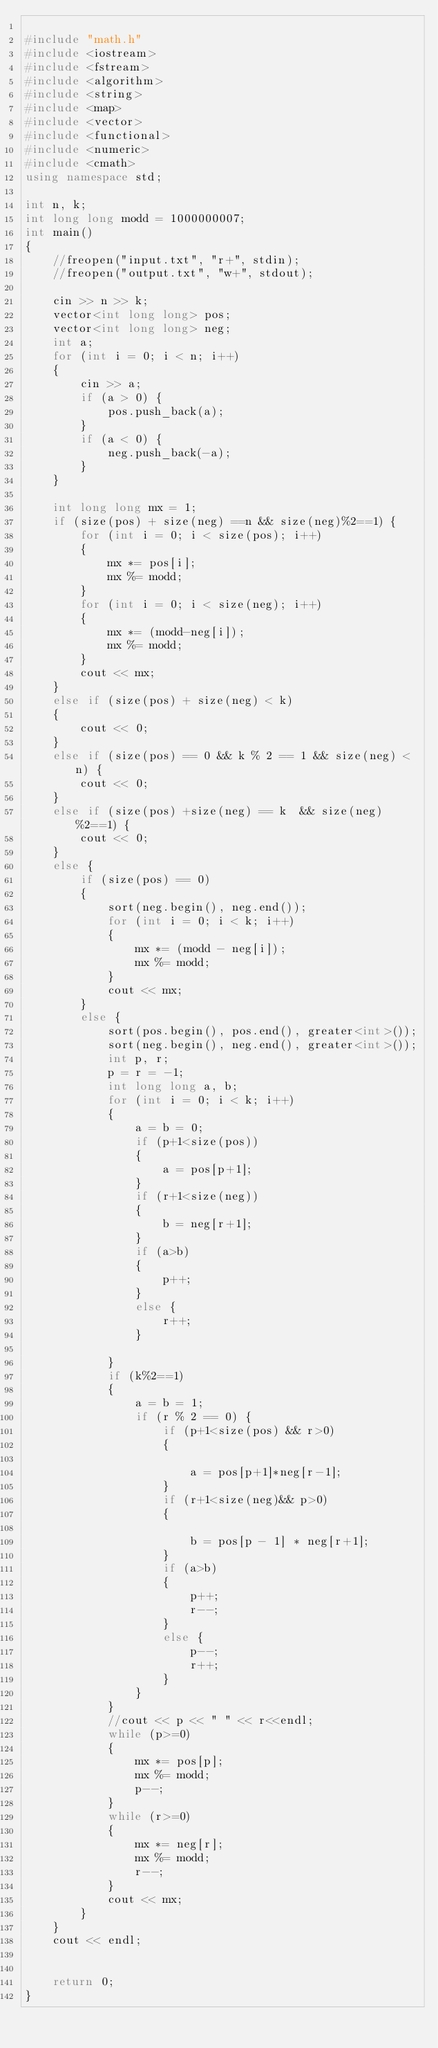Convert code to text. <code><loc_0><loc_0><loc_500><loc_500><_C++_>
#include "math.h"
#include <iostream>
#include <fstream>
#include <algorithm>
#include <string>
#include <map>
#include <vector>
#include <functional>
#include <numeric>
#include <cmath>
using namespace std;

int n, k;
int long long modd = 1000000007;
int main()
{
	//freopen("input.txt", "r+", stdin);
	//freopen("output.txt", "w+", stdout);

	cin >> n >> k;
	vector<int long long> pos;
	vector<int long long> neg;
	int a;
	for (int i = 0; i < n; i++)
	{
		cin >> a;
		if (a > 0) {
			pos.push_back(a);
		}
		if (a < 0) {
			neg.push_back(-a);
		}
	}

	int long long mx = 1;
	if (size(pos) + size(neg) ==n && size(neg)%2==1) {
		for (int i = 0; i < size(pos); i++)
		{
			mx *= pos[i];
			mx %= modd;
		}
		for (int i = 0; i < size(neg); i++)
		{
			mx *= (modd-neg[i]);
			mx %= modd;
		}
		cout << mx;
	}
	else if (size(pos) + size(neg) < k)
	{
		cout << 0;
	}
	else if (size(pos) == 0 && k % 2 == 1 && size(neg) < n) {
		cout << 0;
	}
	else if (size(pos) +size(neg) == k  && size(neg)%2==1) {
		cout << 0;
	}
	else {
		if (size(pos) == 0)
		{
			sort(neg.begin(), neg.end());
			for (int i = 0; i < k; i++)
			{
				mx *= (modd - neg[i]);
				mx %= modd;
			}
			cout << mx;
		}
		else {
			sort(pos.begin(), pos.end(), greater<int>());
			sort(neg.begin(), neg.end(), greater<int>());
			int p, r;
			p = r = -1;
			int long long a, b;
			for (int i = 0; i < k; i++)
			{
				a = b = 0;
				if (p+1<size(pos))
				{
					a = pos[p+1];
				}
				if (r+1<size(neg))
				{
					b = neg[r+1];
				}
				if (a>b)
				{
					p++;
				}
				else {
					r++;
				}
			
			}
			if (k%2==1)
			{
				a = b = 1;
				if (r % 2 == 0) {
					if (p+1<size(pos) && r>0)
					{
						
						a = pos[p+1]*neg[r-1];
					}
					if (r+1<size(neg)&& p>0)
					{
						
						b = pos[p - 1] * neg[r+1];
					}
					if (a>b)
					{
						p++;
						r--;
					}
					else {
						p--;
						r++;
					}
				}
			}
			//cout << p << " " << r<<endl;
			while (p>=0)
			{
				mx *= pos[p];
				mx %= modd;
				p--;
			}
			while (r>=0)
			{
				mx *= neg[r];
				mx %= modd;
				r--;
			}
			cout << mx;
		}
	}
	cout << endl;


	return 0;
}
</code> 